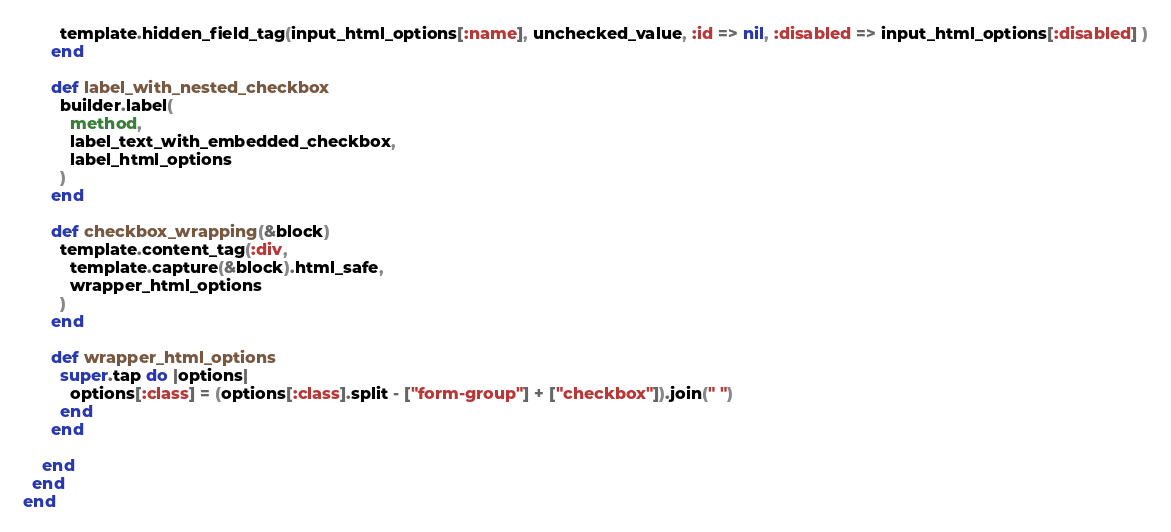Convert code to text. <code><loc_0><loc_0><loc_500><loc_500><_Ruby_>        template.hidden_field_tag(input_html_options[:name], unchecked_value, :id => nil, :disabled => input_html_options[:disabled] )
      end

      def label_with_nested_checkbox
        builder.label(
          method,
          label_text_with_embedded_checkbox,
          label_html_options
        )
      end

      def checkbox_wrapping(&block)
        template.content_tag(:div,
          template.capture(&block).html_safe,
          wrapper_html_options
        )
      end

      def wrapper_html_options
        super.tap do |options|
          options[:class] = (options[:class].split - ["form-group"] + ["checkbox"]).join(" ")
        end
      end

    end
  end
end</code> 